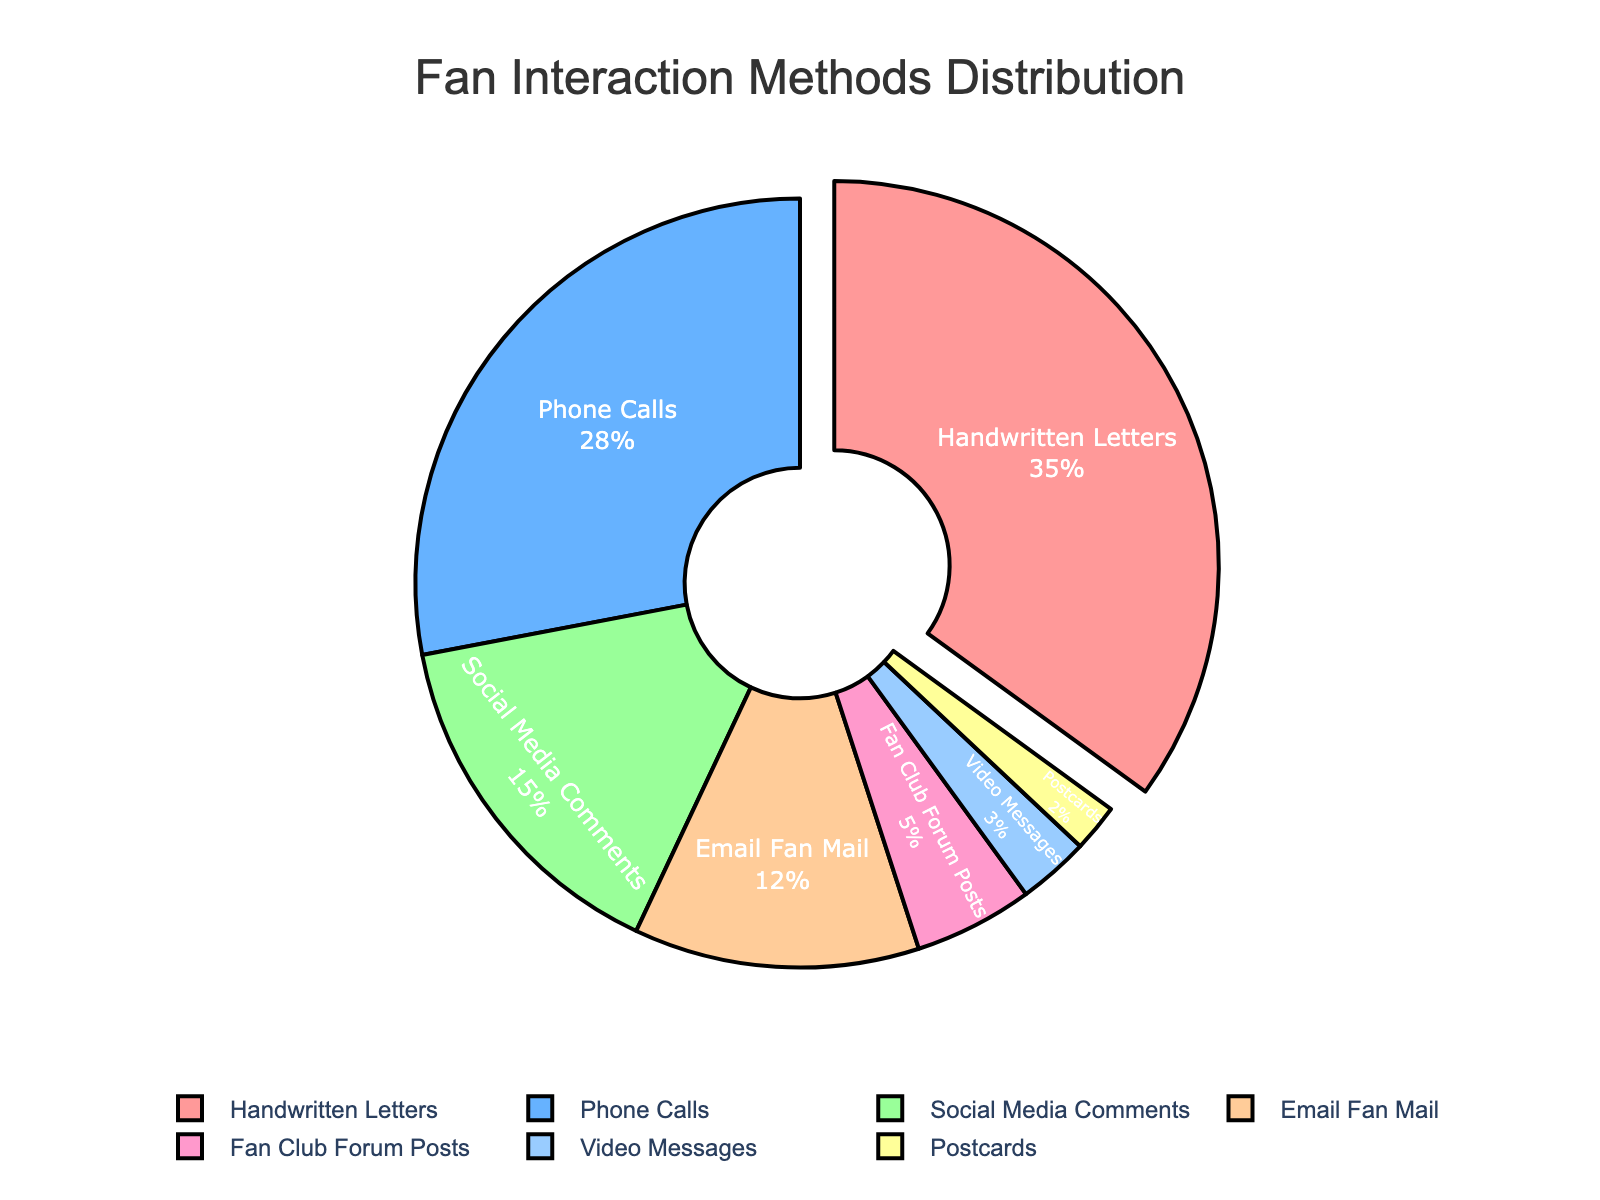Which fan interaction method has the highest percentage? The pie chart highlights the highest percentage segment noticeably. Handwritten Letters occupies the largest segment of the pie chart.
Answer: Handwritten Letters How much more popular are Phone Calls compared to Social Media Comments? From the pie chart, Phone Calls have a percentage of 28%, and Social Media Comments have 15%. The difference is calculated by subtracting the smaller percentage from the larger one. 28% - 15% = 13%.
Answer: 13% What is the combined percentage of Email Fan Mail and Fan Club Forum Posts? From the pie chart, Email Fan Mail has 12%, and Fan Club Forum Posts have 5%. Adding these percentages: 12% + 5% = 17%.
Answer: 17% Which interaction method is least common? On the pie chart, the smallest segment represents the least common interaction method. Postcards have the smallest percentage at 2%.
Answer: Postcards How many methods have a percentage lower than 10%? Examine each segment's percentage on the pie chart and count the methods with percentages lower than 10%. These methods are Fan Club Forum Posts (5%), Video Messages (3%), and Postcards (2%). There are three methods.
Answer: 3 What is the visual cue used to highlight the most popular interaction method? The pie chart uses a slight "pull" or separation of the largest segment to denote the most popular interaction method.
Answer: Pull/Separation What is the total percentage of interactions that are not either Handwritten Letters or Phone Calls? Add the percentages of all interaction methods and then subtract the combined percentage of Handwritten Letters and Phone Calls. Total percentage is 100%. Subtract 35% (Handwritten Letters) and 28% (Phone Calls) from 100%. 100% - (35% + 28%) = 37%.
Answer: 37% Which interaction method is more popular: Video Messages or Fan Club Forum Posts? Compare the segments of Video Messages and Fan Club Forum Posts. Video Messages has 3%, and Fan Club Forum Posts has 5%. Fan Club Forum Posts has a higher percentage.
Answer: Fan Club Forum Posts Are Social Media Comments more than half as popular as Handwritten Letters? Handwritten Letters have 35%, and Social Media Comments have 15%. Half of 35% is 17.5%. Since 15% is not more than 17.5%, Social Media Comments are not more than half as popular as Handwritten Letters.
Answer: No What is the percentage range of the methods with the lowest two interaction rates? Identify the two segments with the lowest percentages: Postcards (2%) and Video Messages (3%). The percentage range is the difference between the highest and lowest of these values: 3% - 2% = 1%.
Answer: 1% 